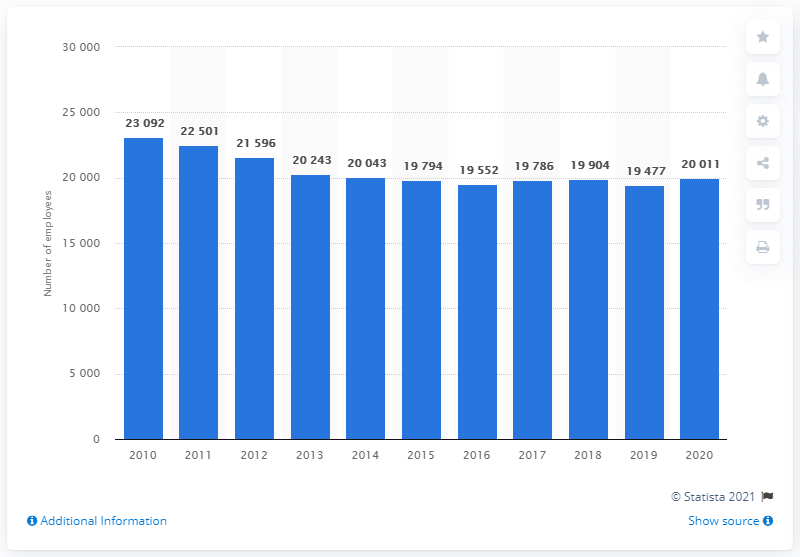Point out several critical features in this image. In 2014, Hydro Quebec had the highest number of permanent and temporary employees. 